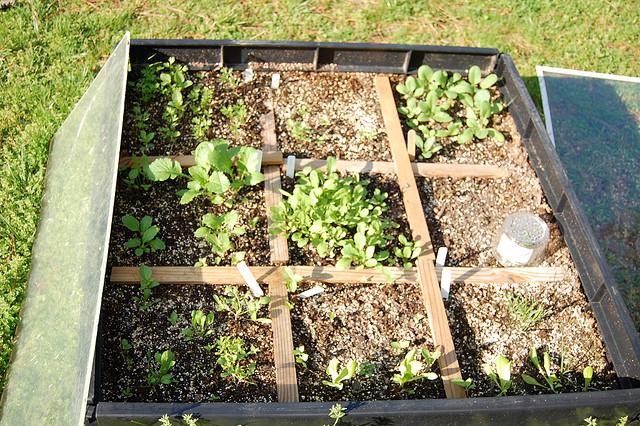How many sections in the garden?
Keep it brief. 9. What is the purpose of this object?
Be succinct. Grow plants. What is this?
Be succinct. Garden. 